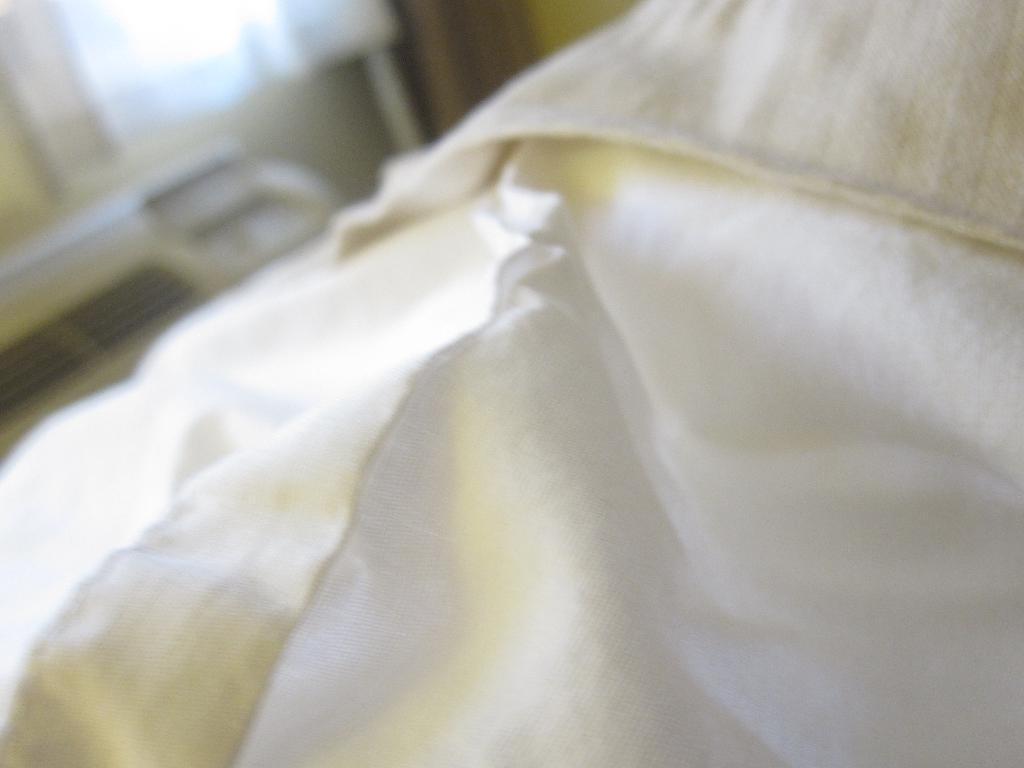What color is the cloth in the image? The cloth in the image is white. How would you describe the background of the image? The background of the image is blurred. What advice does the grandmother give to the person in the image? There is no grandmother or person present in the image, so it is not possible to answer that question. 